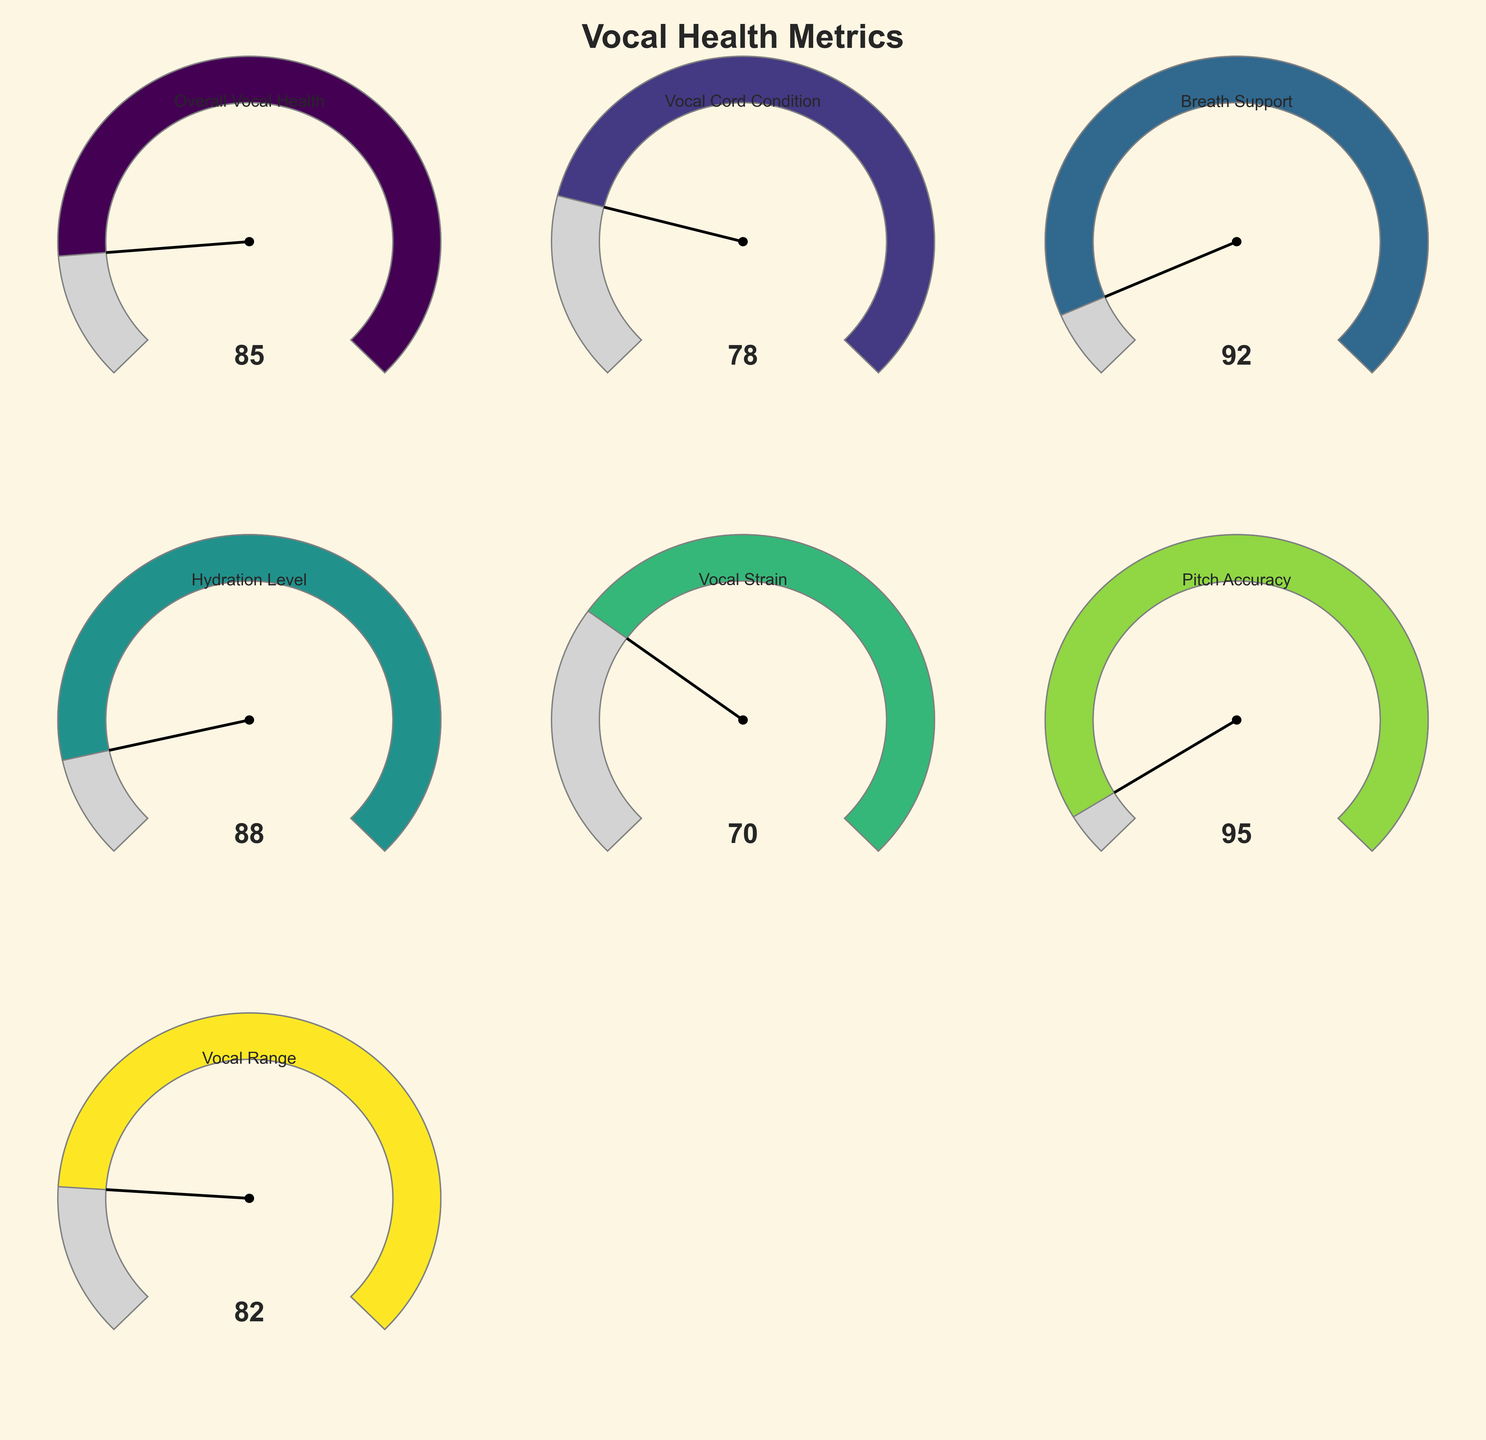Which vocal health metric has the highest value? Scan each of the seven metrics to identify the highest value shown in the gauges. The highest value is in the Pitch Accuracy category.
Answer: Pitch Accuracy What is the overall vocal health value? Locate the gauge labeled "Overall Vocal Health" and note the value displayed on the gauge. The overall vocal health value is 85.
Answer: 85 Which metric indicates the lowest value? Identify the gauge with the lowest needle position and corresponding value. Vocal Strain indicates the lowest value, which is 70.
Answer: Vocal Strain What is the average value of Vocal Cord Condition and Hydration Level? Add the values for Vocal Cord Condition and Hydration Level (78 and 88). Then, divide the result by 2 to get the average. (78 + 88) / 2 = 83.
Answer: 83 How does the Breath Support value compare to the Vocal Cord Condition value? Compare the values directly by locating the Breath Support (92) and Vocal Cord Condition (78) gauges and noting that Breath Support is higher.
Answer: Breath Support is higher Is the Vocal Range metric above or below 85? Locate the Vocal Range gauge and check its value. The Vocal Range value is 82, which is below 85.
Answer: Below 85 What is the range of the values shown in the gauges? Identify the minimum and maximum values across all gauges (70 and 95). Subtract the minimum value from the maximum value to determine the range. (95 - 70 = 25).
Answer: 25 If the Vocal Strain value increased by 10, what would the new value be? Add 10 to the current Vocal Strain value of 70. The new value would be 70 + 10 = 80.
Answer: 80 Which metric is closest to its maximum value? Evaluate how close each metric’s value is to its maximum value, centered on the percentage filled in each gauge. Pitch Accuracy is closest with a value of 95 out of 100.
Answer: Pitch Accuracy 